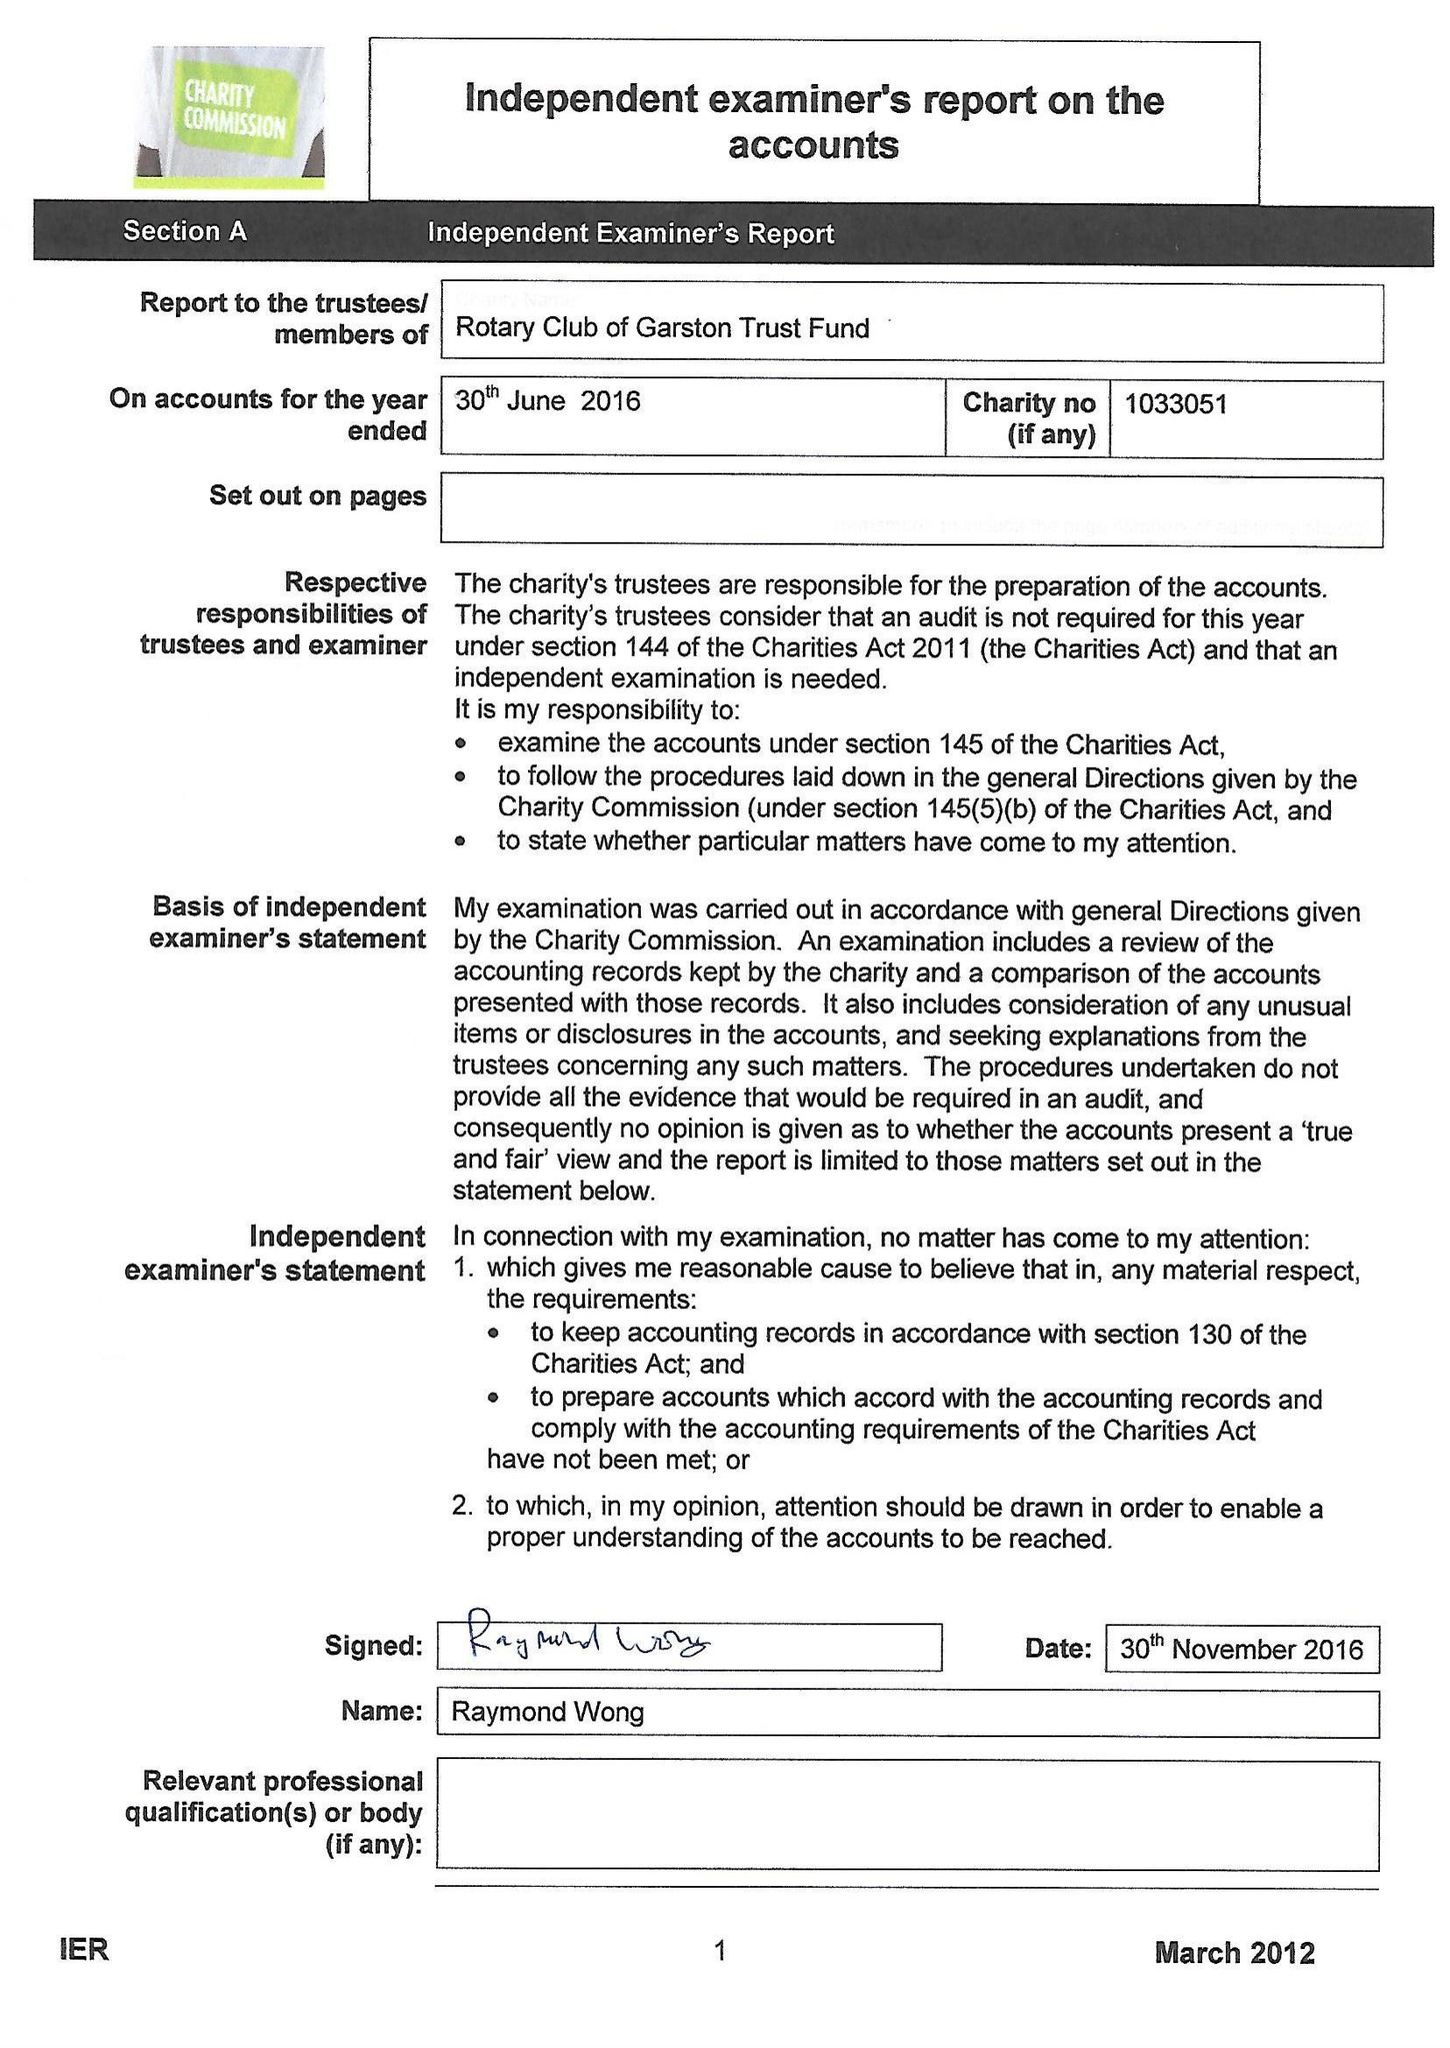What is the value for the charity_name?
Answer the question using a single word or phrase. Rotary Club Of Garston Trust Fund 